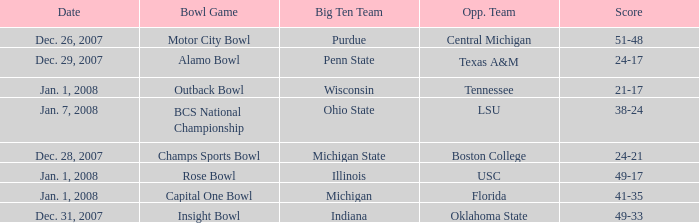What bowl game was played on Dec. 26, 2007? Motor City Bowl. 